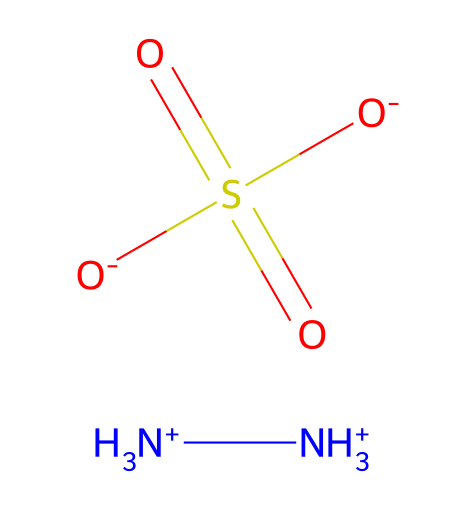What is the total number of nitrogen atoms in hydrazine sulfate? The SMILES representation indicates two NH3+ groups, each containing one nitrogen atom. Thus, the total number of nitrogen atoms is 2.
Answer: 2 How many sulfonate groups are present in hydrazine sulfate? The SMILES notation includes one occurrence of the sulfonate group (S(=O)(=O)[O-]), indicating that there is only one sulfonate group.
Answer: 1 Which functional group makes hydrazine sulfate a reducing agent? The presence of the nitrogen atoms in the structure indicates that it has reducing properties, as nitrogen can donate electrons.
Answer: nitrogen What is the oxidation state of sulfur in hydrazine sulfate? In the structure, sulfur is bonded to three oxygen atoms (two as double bonds and one as a single bond), leading to an oxidation state of +6.
Answer: +6 What type of bonding is primarily present between nitrogen atoms in hydrazine sulfate? The bonding between the nitrogen atoms is covalent, as nitrogen shares electrons with other atoms to form the NH3+ groups.
Answer: covalent How many oxygen atoms are attached to sulfur in hydrazine sulfate? The structure shows that sulfur is bonded to four oxygen atoms (three as hydroxyl and two as double bonded), thus there are 4 oxygen atoms attached to sulfur.
Answer: 4 